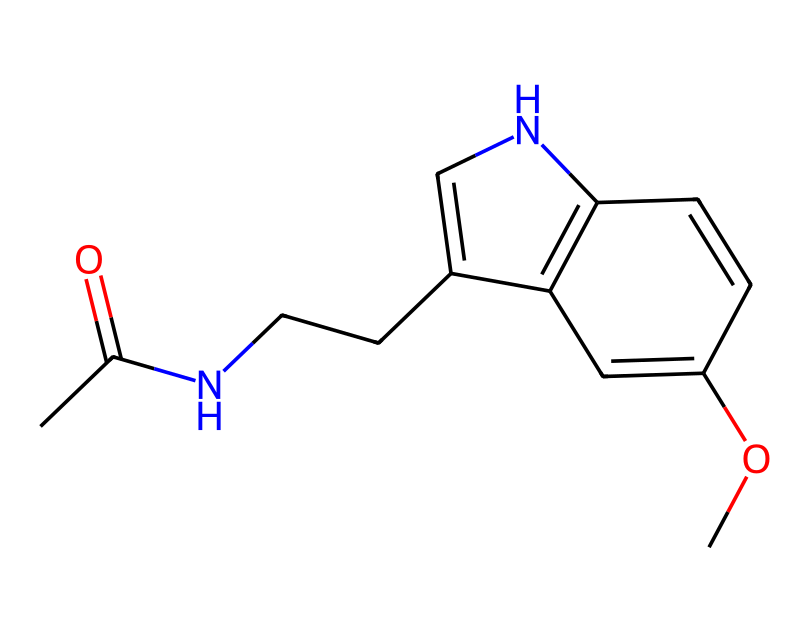How many carbon atoms are present in this molecule? To determine the number of carbon atoms, examine the structure derived from the SMILES representation. In the provided structure, each "C" represents a carbon atom. By counting all the "C" characters, we find there are 12 carbons in total.
Answer: 12 What type of functional group is present in melatonin? Analyzing the structure, we note the presence of an amide group (–C(=O)N–) and a methoxy group (–OCH3). The defining characteristic of melatonin is the amide group, which contributes to its functional properties.
Answer: amide How many double bonds are present in the structure? By inspecting the SMILES and structure, double bonds are indicated by "=" signs. Counting these, we observe a total of 4 double bonds in the overall structure of melatonin.
Answer: 4 What is the relationship between melatonin and sleep regulation? Melatonin's structural components allow it to interact with receptors in the brain, particularly the melatonin receptors. This interaction is crucial for regulating circadian rhythms and promoting sleep.
Answer: sleep regulation Is melatonin classified as a steroid or peptide hormone? Melatonin is derived from the amino acid tryptophan and fits neither the classification of steroid (derived from cholesterol) nor peptide hormones (composed of amino acids). It is classified as an indoleamine hormone.
Answer: indoleamine 